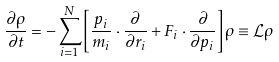<formula> <loc_0><loc_0><loc_500><loc_500>\frac { \partial \rho } { \partial t } = - \sum _ { i = 1 } ^ { N } \left [ \frac { p _ { i } } { m _ { i } } \cdot \frac { \partial } { \partial r _ { i } } + F _ { i } \cdot \frac { \partial } { \partial p _ { i } } \right ] \rho \equiv \mathcal { L } \rho</formula> 